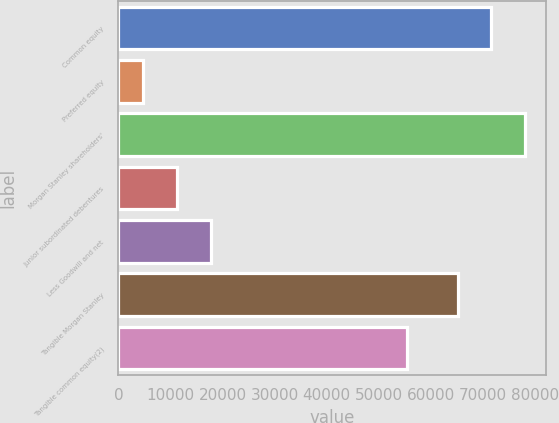Convert chart to OTSL. <chart><loc_0><loc_0><loc_500><loc_500><bar_chart><fcel>Common equity<fcel>Preferred equity<fcel>Morgan Stanley shareholders'<fcel>Junior subordinated debentures<fcel>Less Goodwill and net<fcel>Tangible Morgan Stanley<fcel>Tangible common equity(2)<nl><fcel>71715.4<fcel>4774<fcel>78243.8<fcel>11302.4<fcel>17830.8<fcel>65187<fcel>55547<nl></chart> 